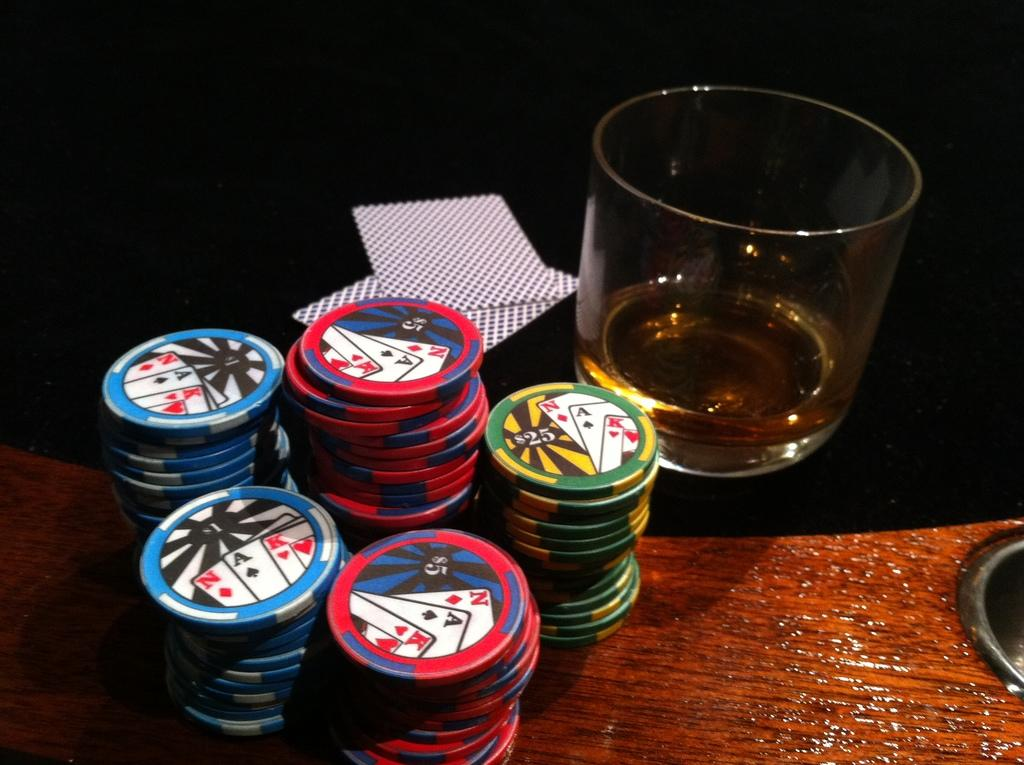What type of surface is at the bottom of the image? There is a wooden surface at the bottom of the image. What objects are on the wooden surface? Coins are present on the wooden surface. What is covering part of the wooden surface? There is a black cloth on the wooden surface. What items are on the black cloth? Cards are on the black cloth, and there is a glass with liquid on the black cloth. What type of apparel is the stranger wearing in the image? There is no stranger present in the image, so it is not possible to determine what type of apparel they might be wearing. 